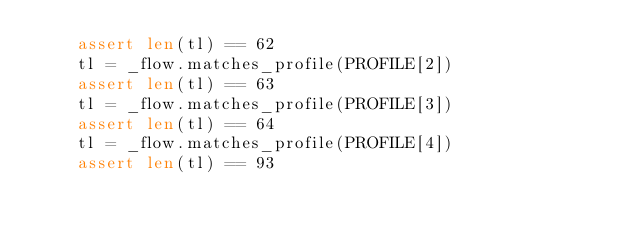<code> <loc_0><loc_0><loc_500><loc_500><_Python_>    assert len(tl) == 62
    tl = _flow.matches_profile(PROFILE[2])
    assert len(tl) == 63
    tl = _flow.matches_profile(PROFILE[3])
    assert len(tl) == 64
    tl = _flow.matches_profile(PROFILE[4])
    assert len(tl) == 93</code> 